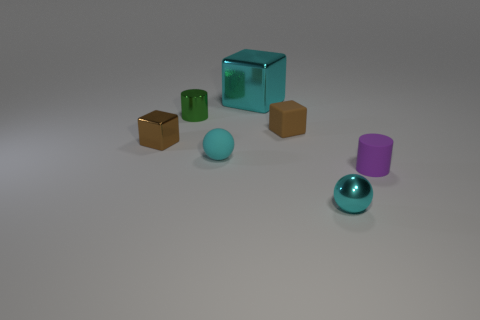Is the color of the cylinder to the right of the tiny shiny cylinder the same as the metal thing on the left side of the green shiny cylinder?
Ensure brevity in your answer.  No. Is there anything else that is the same size as the brown matte thing?
Offer a terse response. Yes. Are there any large cyan shiny cubes in front of the large cyan metallic object?
Offer a terse response. No. How many other large metallic things have the same shape as the large shiny object?
Keep it short and to the point. 0. The shiny cube in front of the tiny metallic cylinder on the left side of the sphere in front of the cyan matte object is what color?
Make the answer very short. Brown. Do the tiny cylinder behind the brown rubber cube and the brown cube that is in front of the small brown matte object have the same material?
Give a very brief answer. Yes. What number of things are either brown cubes on the left side of the big cyan object or cyan shiny objects?
Provide a short and direct response. 3. What number of objects are either big gray shiny cubes or purple matte objects right of the cyan cube?
Give a very brief answer. 1. How many green metal objects are the same size as the brown matte thing?
Give a very brief answer. 1. Are there fewer cyan things that are behind the small purple matte cylinder than matte cylinders left of the tiny matte block?
Your answer should be compact. No. 